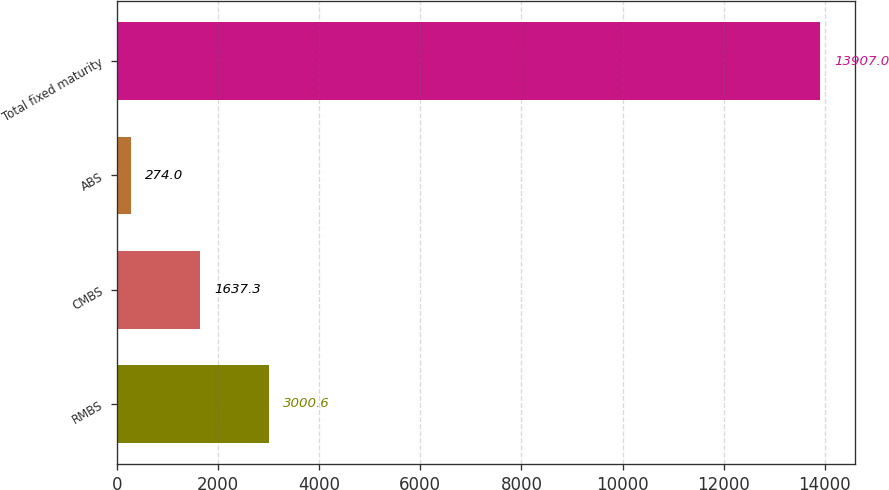Convert chart. <chart><loc_0><loc_0><loc_500><loc_500><bar_chart><fcel>RMBS<fcel>CMBS<fcel>ABS<fcel>Total fixed maturity<nl><fcel>3000.6<fcel>1637.3<fcel>274<fcel>13907<nl></chart> 